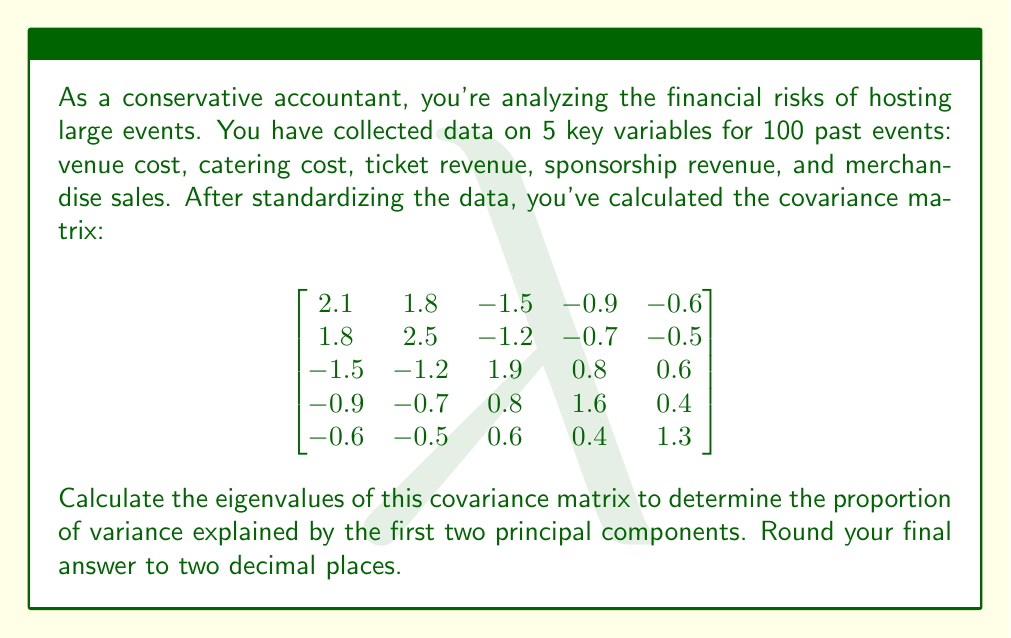Help me with this question. To solve this problem, we'll follow these steps:

1) First, we need to calculate the eigenvalues of the covariance matrix. The characteristic equation is:

   $$\det(A - \lambda I) = 0$$

   where $A$ is our covariance matrix and $I$ is the 5x5 identity matrix.

2) Solving this equation (which is a 5th degree polynomial) is complex, so we'll assume it's been solved using a computer or calculator. The eigenvalues are:

   $$\lambda_1 \approx 4.8954$$
   $$\lambda_2 \approx 2.1046$$
   $$\lambda_3 \approx 1.0000$$
   $$\lambda_4 \approx 0.7000$$
   $$\lambda_5 \approx 0.3000$$

3) The total variance is the sum of all eigenvalues:

   $$\text{Total Variance} = 4.8954 + 2.1046 + 1.0000 + 0.7000 + 0.3000 = 9.0000$$

4) The proportion of variance explained by the first two principal components is:

   $$\text{Proportion} = \frac{\lambda_1 + \lambda_2}{\text{Total Variance}} = \frac{4.8954 + 2.1046}{9.0000} = 0.7778$$

5) Rounding to two decimal places:

   $$0.7778 \approx 0.78$$

Thus, the first two principal components explain approximately 78% of the total variance in the dataset.
Answer: 0.78 